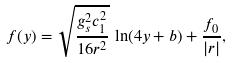<formula> <loc_0><loc_0><loc_500><loc_500>f ( y ) = \sqrt { \frac { g _ { s } ^ { 2 } c _ { 1 } ^ { 2 } } { 1 6 r ^ { 2 } } } \, \ln ( 4 y + b ) + \frac { f _ { 0 } } { | r | } ,</formula> 